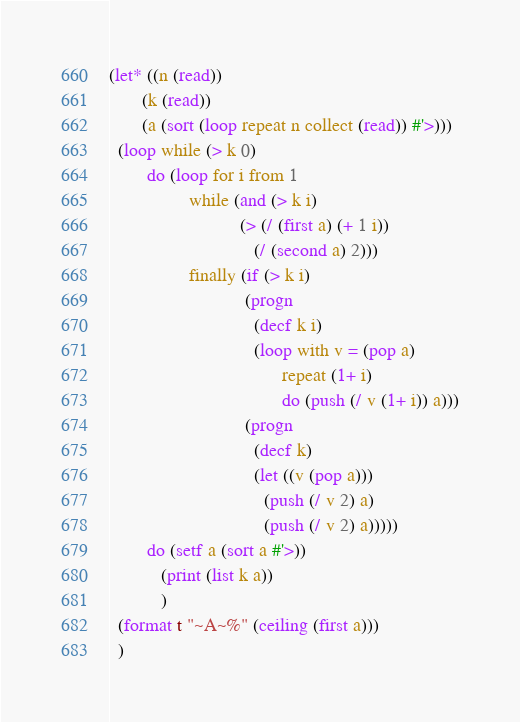Convert code to text. <code><loc_0><loc_0><loc_500><loc_500><_Lisp_>(let* ((n (read))
       (k (read))
       (a (sort (loop repeat n collect (read)) #'>)))
  (loop while (> k 0)
        do (loop for i from 1
                 while (and (> k i)
                            (> (/ (first a) (+ 1 i))
                               (/ (second a) 2)))
                 finally (if (> k i)
                             (progn
                               (decf k i)
                               (loop with v = (pop a)
                                     repeat (1+ i)
                                     do (push (/ v (1+ i)) a)))
                             (progn
                               (decf k)
                               (let ((v (pop a)))
                                 (push (/ v 2) a)
                                 (push (/ v 2) a)))))
        do (setf a (sort a #'>))
           (print (list k a))
           )
  (format t "~A~%" (ceiling (first a)))
  )
</code> 